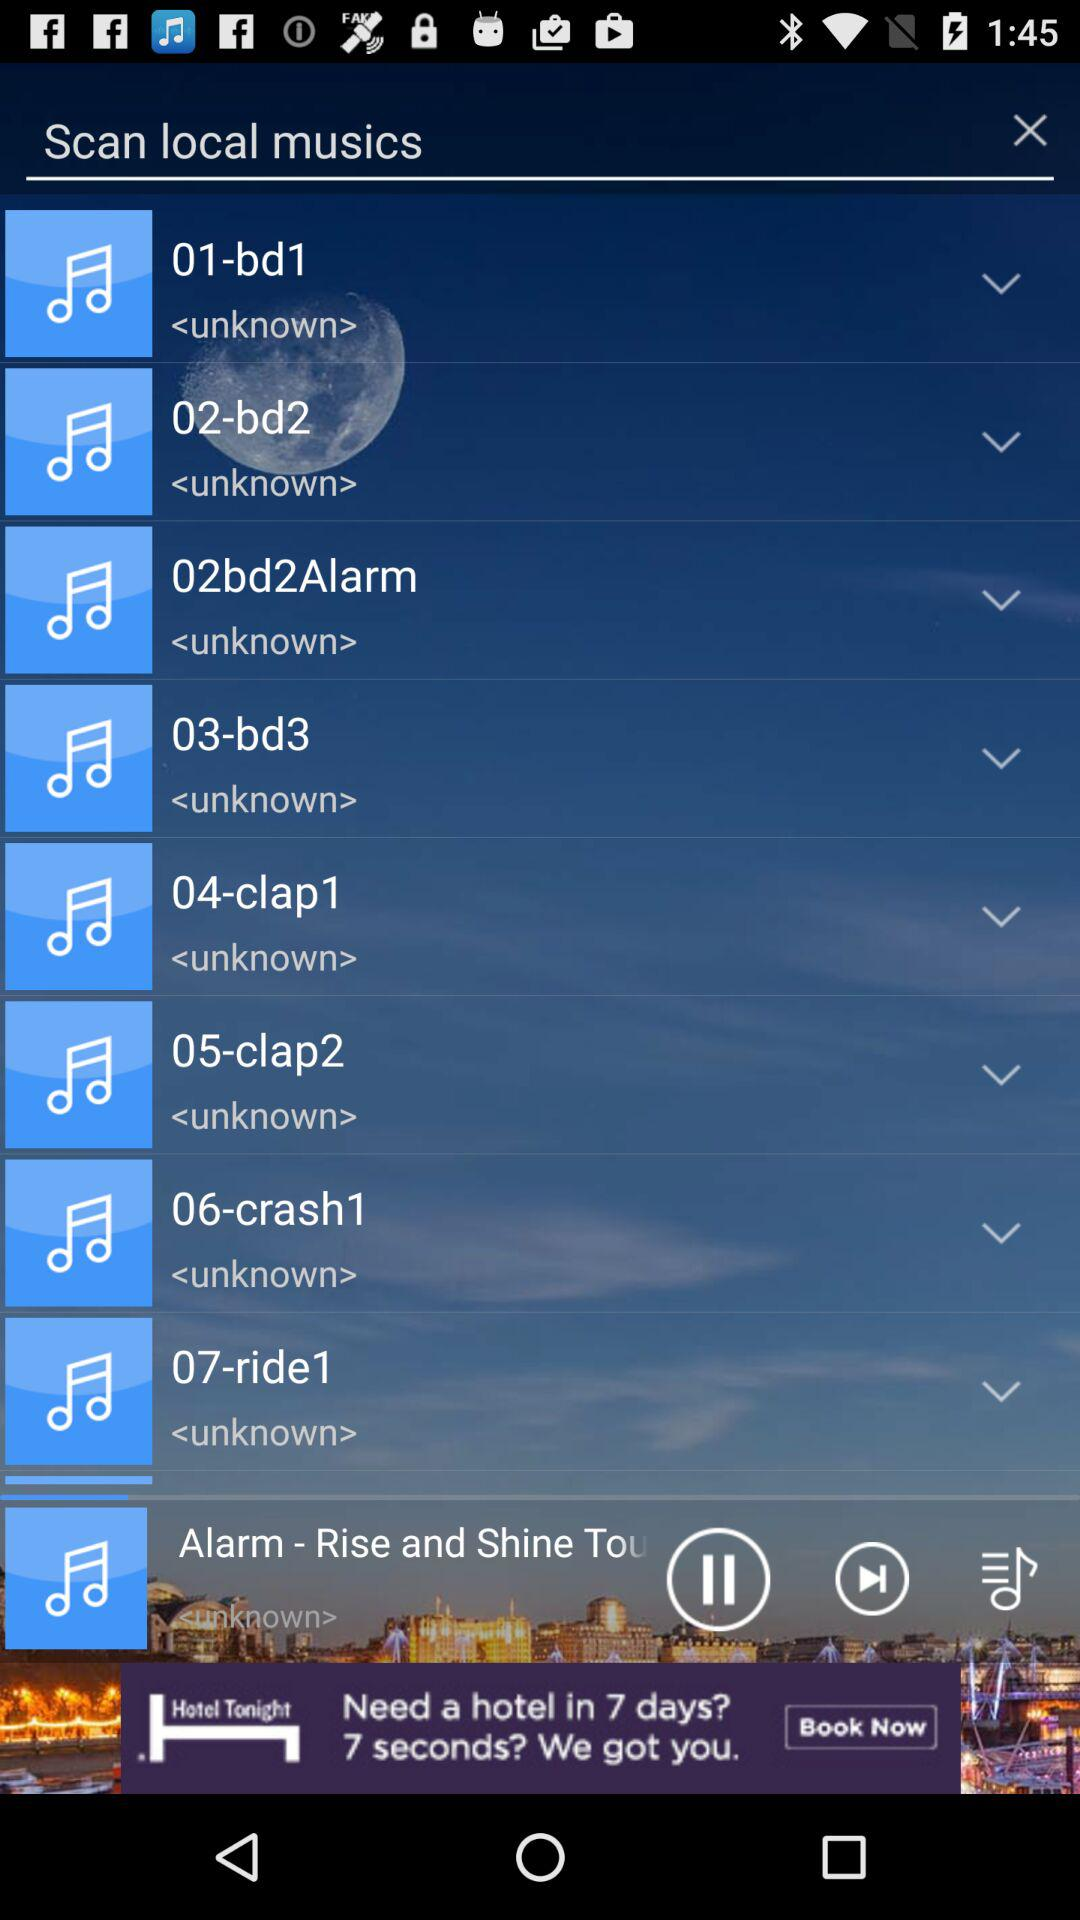What is the name of current playing song? The name is "Alarm - Rise and Shine Tou". 